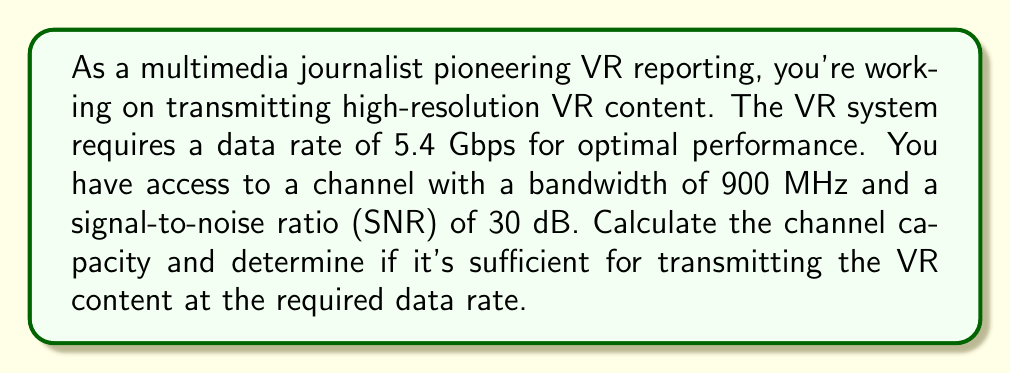Could you help me with this problem? To solve this problem, we'll use the Shannon-Hartley theorem to calculate the channel capacity. The theorem states that:

$$C = B \log_2(1 + SNR)$$

Where:
$C$ = Channel capacity in bits per second (bps)
$B$ = Bandwidth in Hertz (Hz)
$SNR$ = Signal-to-Noise Ratio (linear scale)

Step 1: Convert the given SNR from dB to linear scale
$SNR_{linear} = 10^{(SNR_{dB} / 10)}$
$SNR_{linear} = 10^{(30 / 10)} = 1000$

Step 2: Apply the Shannon-Hartley theorem
$C = 900 \times 10^6 \log_2(1 + 1000)$

Step 3: Simplify the calculation
$C = 900 \times 10^6 \times \log_2(1001)$
$C = 900 \times 10^6 \times 9.97$
$C = 8.973 \times 10^9$ bps
$C \approx 8.97$ Gbps

Step 4: Compare the calculated channel capacity to the required data rate
The calculated channel capacity (8.97 Gbps) is greater than the required data rate (5.4 Gbps) for the VR system.
Answer: The channel capacity is approximately 8.97 Gbps, which is sufficient for transmitting the high-resolution VR content at the required data rate of 5.4 Gbps. 